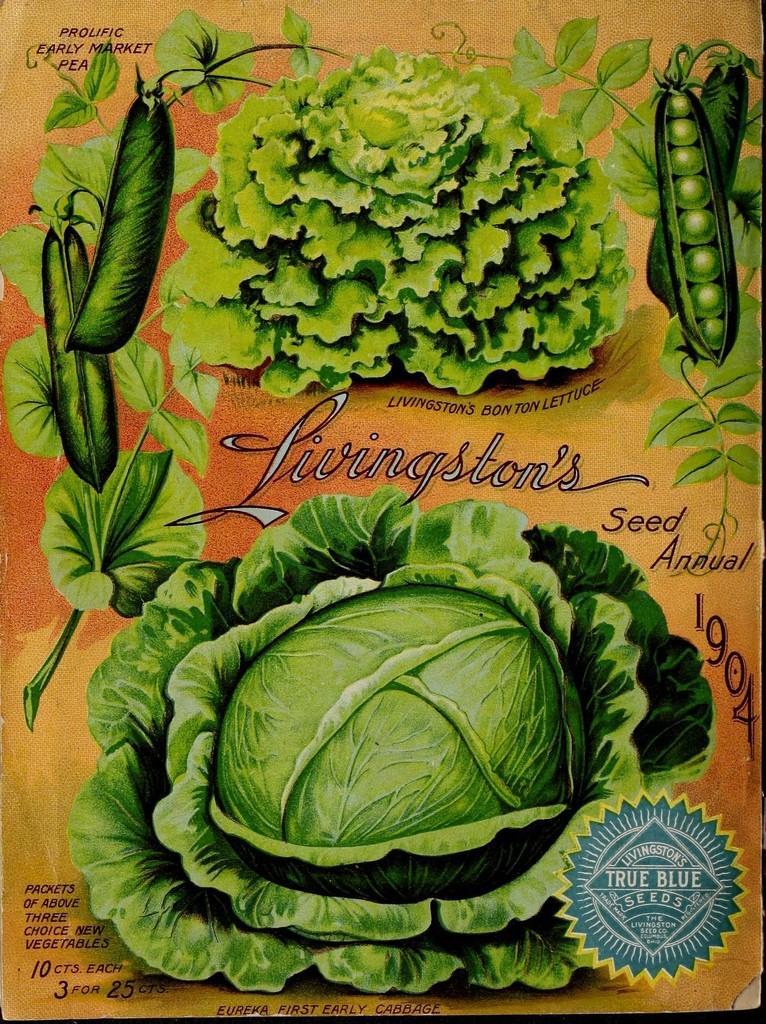In one or two sentences, can you explain what this image depicts? In the image we can see a poster and in the poster there are pictures of vegetables and there is even a text. 